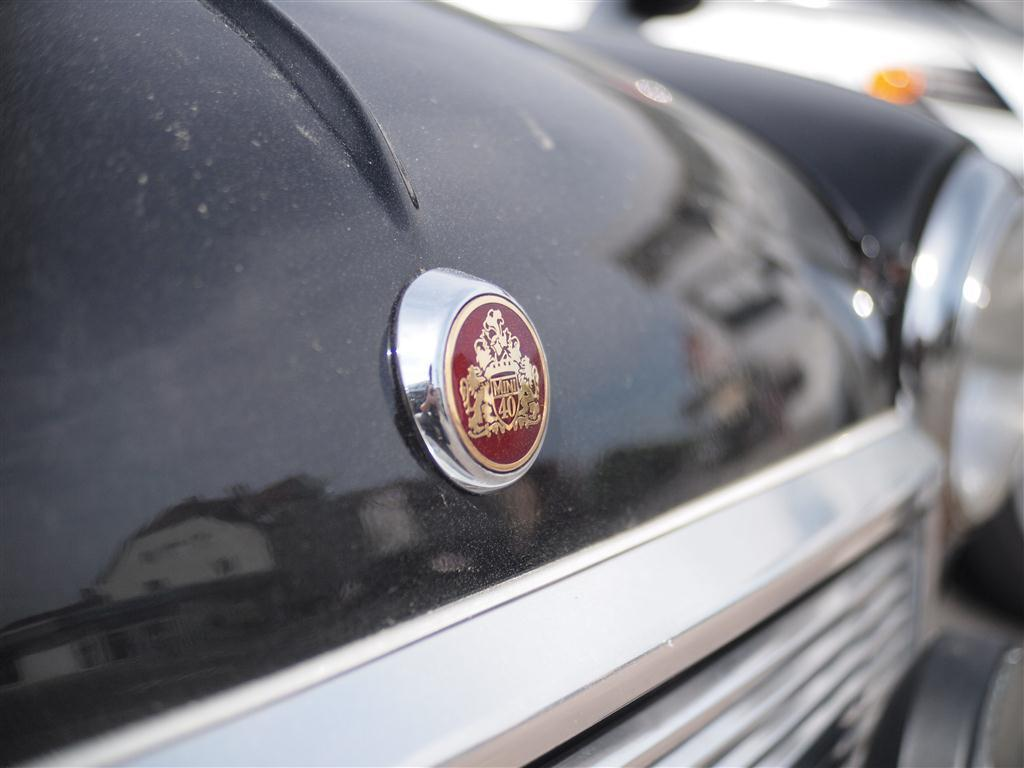What is the main subject of the image? The main subject of the image is a car. Can you describe any specific details about the car? The image is a zoomed in picture of the car, so we can see a logo visible in the image. What type of shelf can be seen in the image? There is no shelf present in the image; it is a zoomed in picture of a car. How does the logo in the image express disgust? The logo in the image does not express any emotion, including disgust, as it is an inanimate object. 